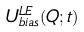<formula> <loc_0><loc_0><loc_500><loc_500>U _ { b i a s } ^ { L E } ( Q ; t )</formula> 